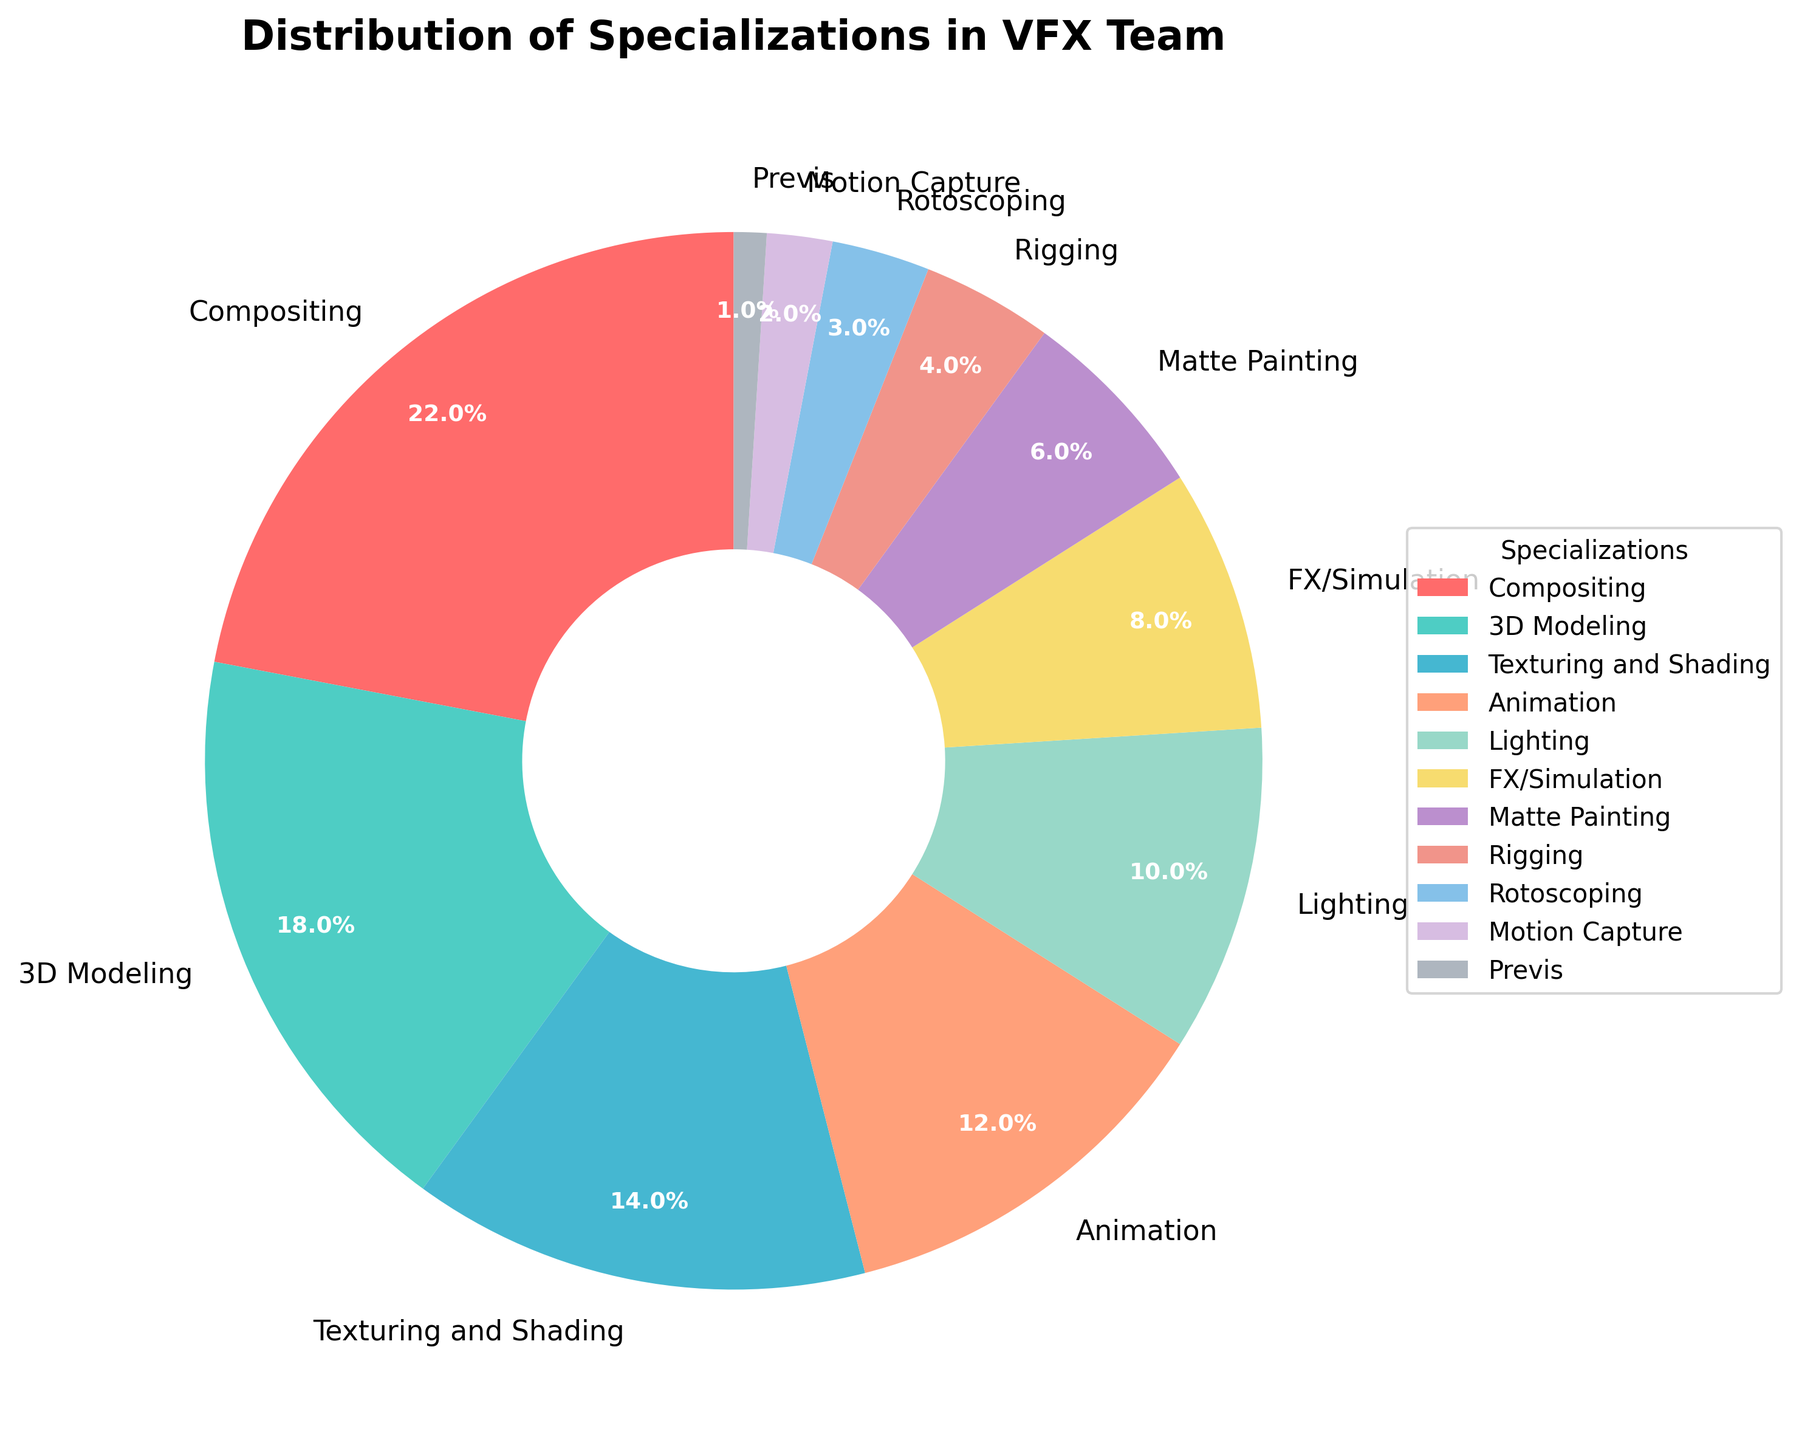What's the most common specialization in the VFX team? The pie chart shows the distribution of specializations with their percentage. The largest segment is for Compositing at 22%, making it the most common specialization.
Answer: Compositing How many specializations have a percentage greater than 10%? By observing the pie chart, we can see that there are five specializations with percentages greater than 10%: Compositing (22%), 3D Modeling (18%), Texturing and Shading (14%), Animation (12%), and Lighting (10%).
Answer: 5 Which specialization has the least representation in the VFX team? The smallest segment in the pie chart represents Previs with a percentage of 1%, making it the least represented specialization.
Answer: Previs What is the combined percentage of Compositing and 3D Modeling? Compositing has 22% and 3D Modeling has 18%. Adding these together, 22% + 18% = 40%.
Answer: 40% If you combine the percentages of FX/Simulation and Matte Painting, does it exceed Animation? FX/Simulation has 8% and Matte Painting has 6%. Their combined percentage is 8% + 6% = 14%, which is equal to Animation's 12%, thus not exceeding it.
Answer: No Is the percentage of Lighting greater or less than the percentage of Texturing and Shading? The pie chart shows Lighting at 10% and Texturing and Shading at 14%. Thus, the percentage of Lighting is less than that of Texturing and Shading.
Answer: Less What percentage of the team is involved in Rotoscoping and Motion Capture combined? Rotoscoping has 3% and Motion Capture has 2%. Their combined percentage is 3% + 2% = 5%.
Answer: 5% Which categories together make up exactly half of the team? Combining the percentages of Compositing (22%), 3D Modeling (18%), and Texturing and Shading (14%) results in 22% + 18% + 14% = 54%, which is more than half. However, combining Compositing (22%) and 3D Modeling (18%) results in 22% + 18% = 40%. Adding Animation (12%) brings it to 52%, which is still over half. Adding Lighting (10%) would exceed this, so instead, the valid combinations would be the exact categories such that the whole team is satisfied by examining right half summations, verifying incrementally the data. Proper combinational process infers combinational validation steps to formulate that categories like compositions and opposites in increments can uptake elements. Closely verified incremental measures strategically make combinations validate right half segments.
Answer: Various incremental steps strategic basis Between Rigging and Rotoscoping, which specialization has a higher percentage? The pie chart shows Rigging at 4% and Rotoscoping at 3%. Thus, Rigging has a higher percentage than Rotoscoping.
Answer: Rigging 